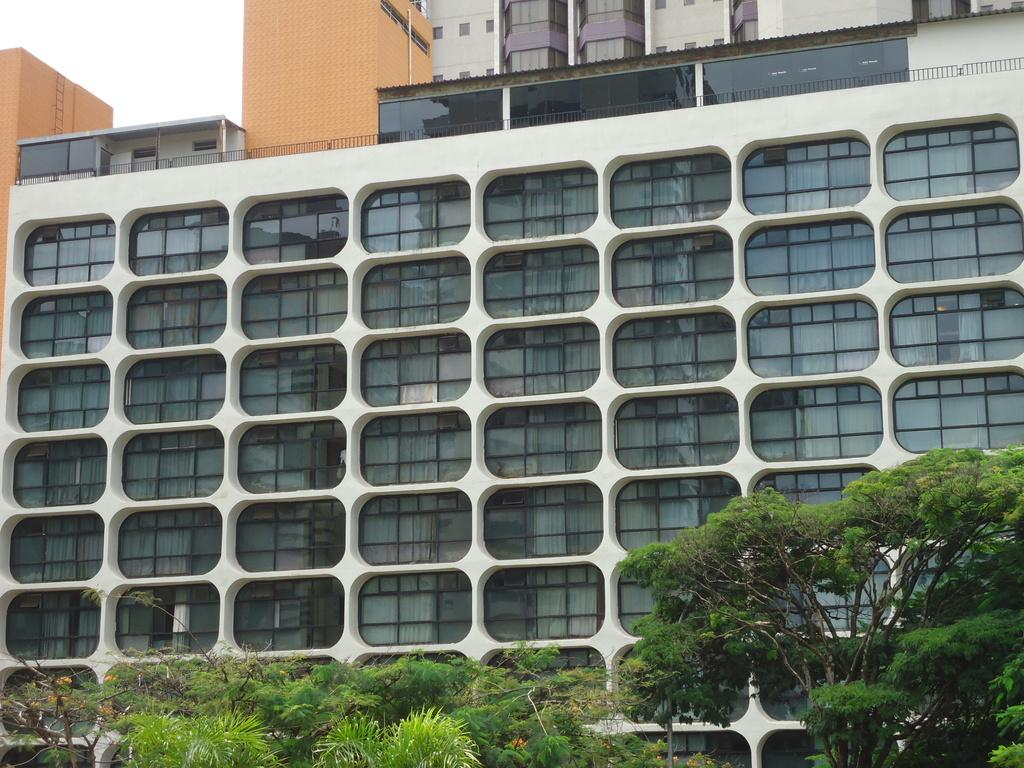What type of structures can be seen in the image? There are buildings in the image. What other natural elements are present in the image? There are trees in the image. What part of the natural environment is visible in the image? The sky is visible in the image. What type of question is being asked in the image? There is no question being asked in the image; it is a visual representation of buildings, trees, and the sky. 